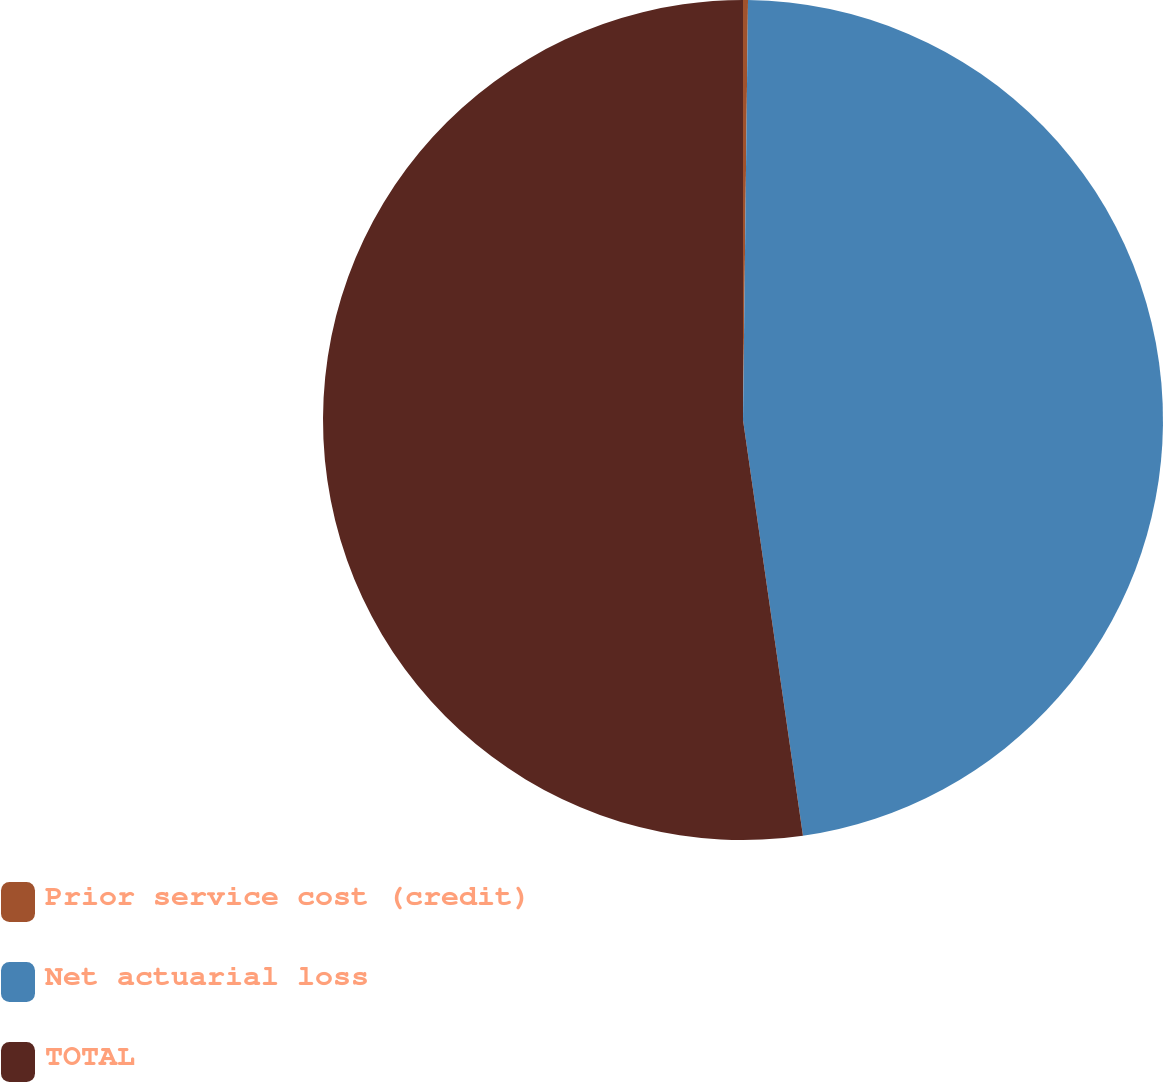Convert chart to OTSL. <chart><loc_0><loc_0><loc_500><loc_500><pie_chart><fcel>Prior service cost (credit)<fcel>Net actuarial loss<fcel>TOTAL<nl><fcel>0.19%<fcel>47.53%<fcel>52.28%<nl></chart> 